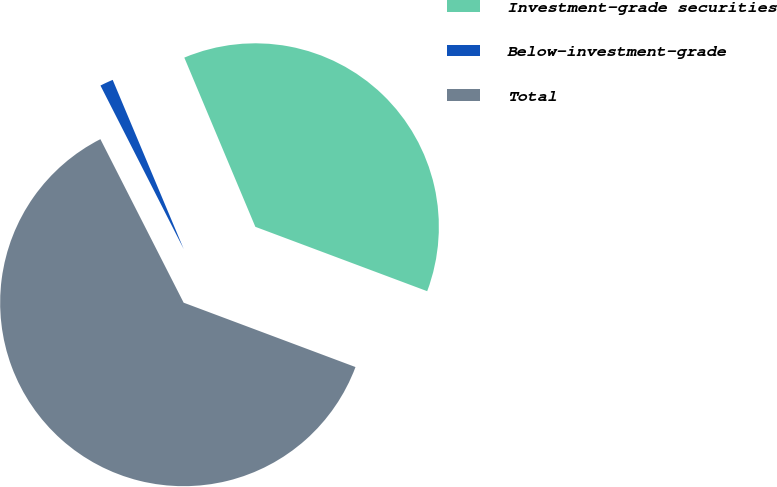<chart> <loc_0><loc_0><loc_500><loc_500><pie_chart><fcel>Investment-grade securities<fcel>Below-investment-grade<fcel>Total<nl><fcel>37.03%<fcel>1.17%<fcel>61.8%<nl></chart> 